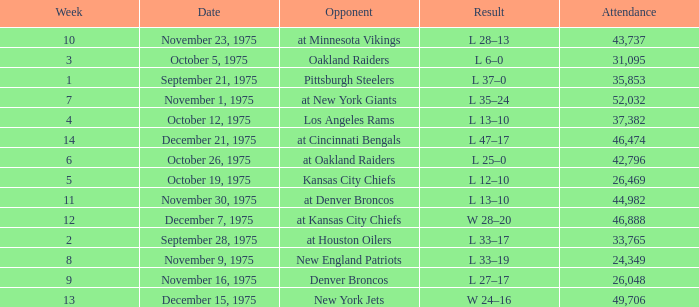What is the average Week when the result was w 28–20, and there were more than 46,888 in attendance? None. 